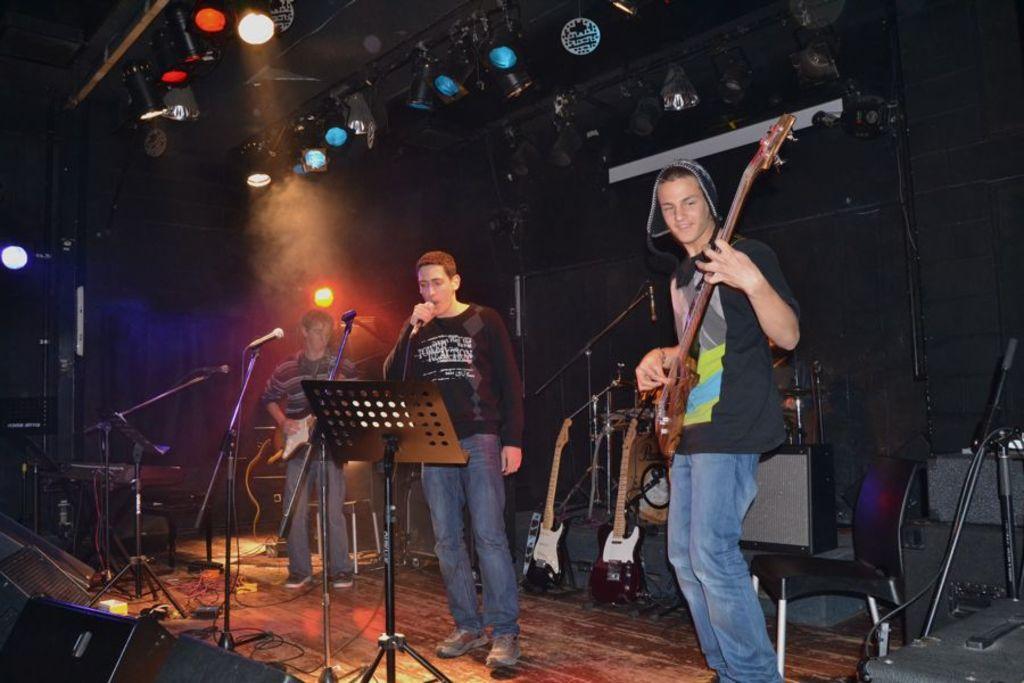How would you summarize this image in a sentence or two? A rock band is performing on a stage in a concert. Of them a man is singing with a mic in the canter and two other are playing guitars on either side. 